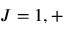<formula> <loc_0><loc_0><loc_500><loc_500>J = 1 , +</formula> 